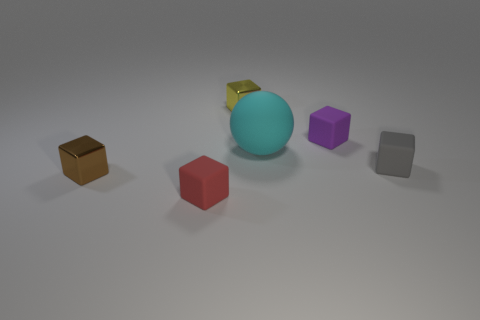Subtract all brown blocks. How many blocks are left? 4 Subtract all small brown shiny cubes. How many cubes are left? 4 Subtract all cyan cubes. Subtract all yellow cylinders. How many cubes are left? 5 Add 3 big cyan matte balls. How many objects exist? 9 Subtract all balls. How many objects are left? 5 Subtract all big yellow balls. Subtract all tiny matte cubes. How many objects are left? 3 Add 4 cubes. How many cubes are left? 9 Add 4 large gray things. How many large gray things exist? 4 Subtract 0 red cylinders. How many objects are left? 6 